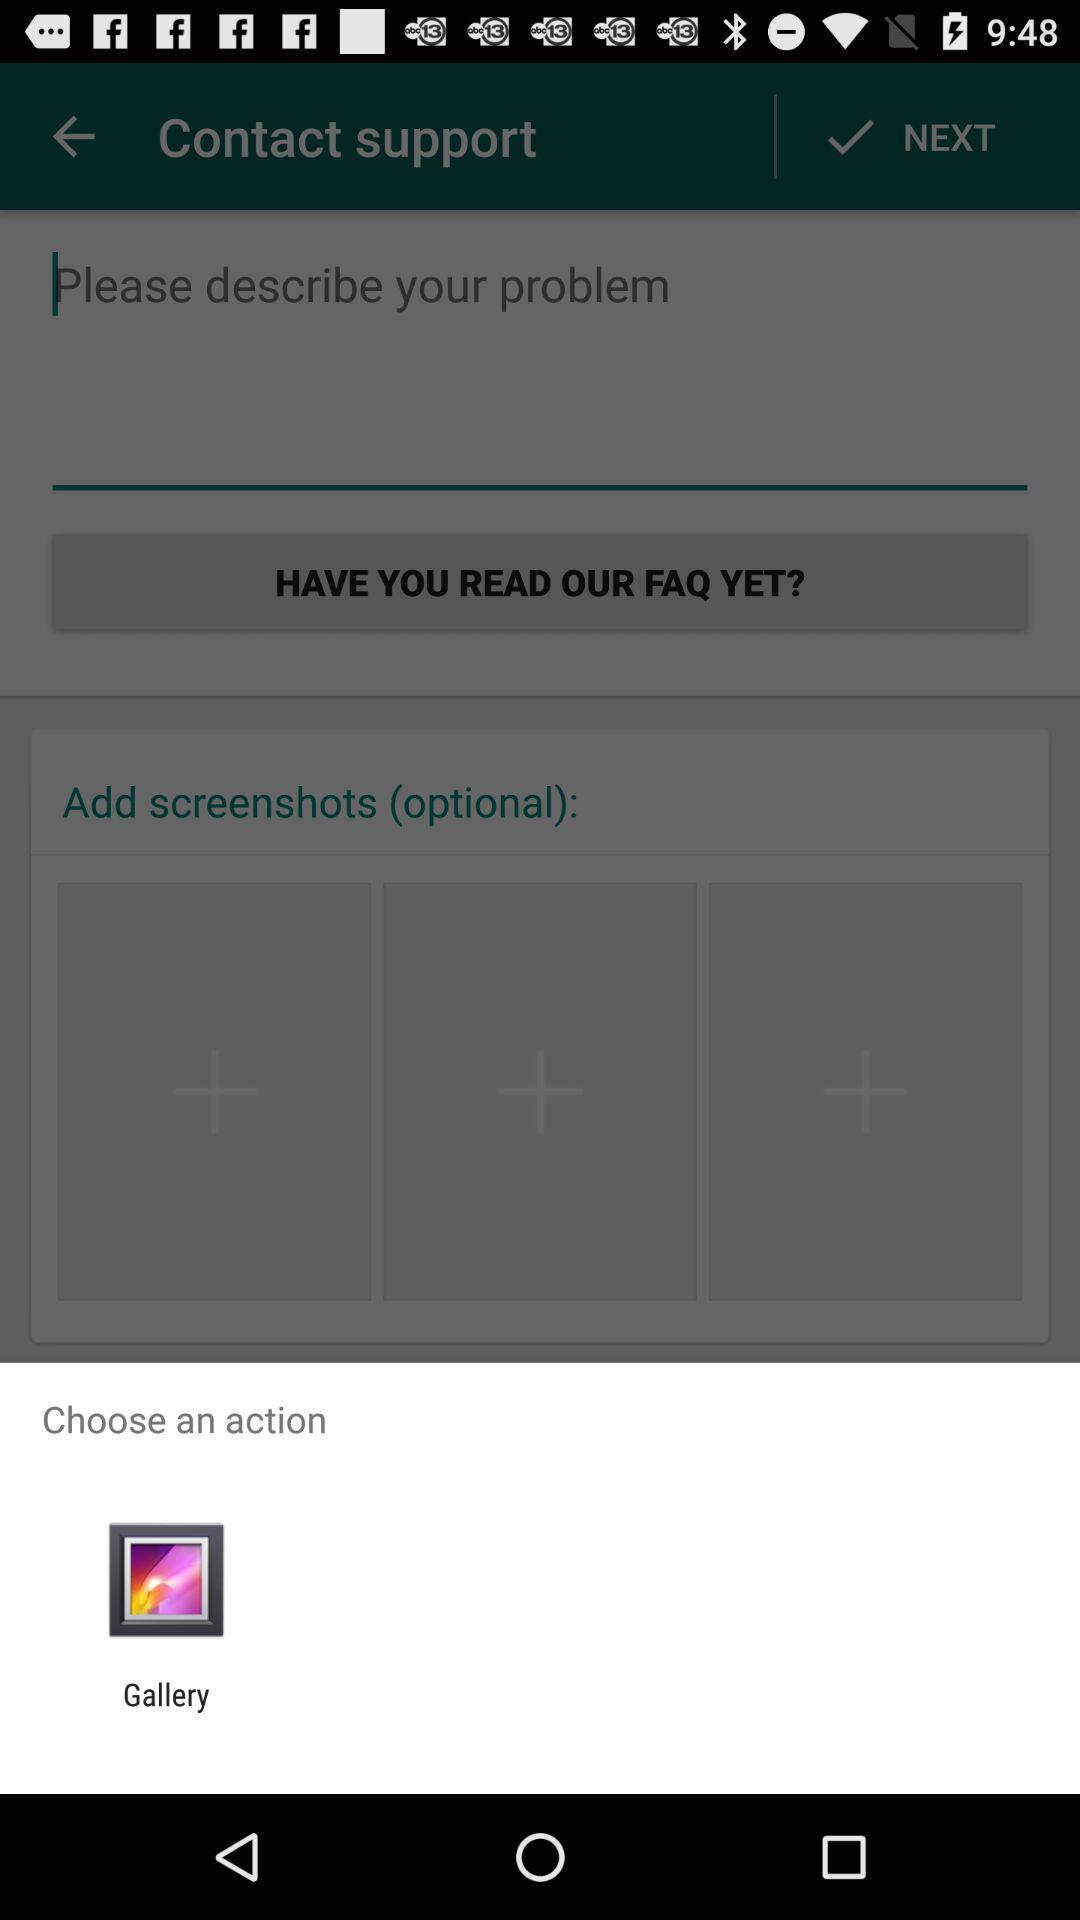What are the available options for action? The available option is "Gallery". 